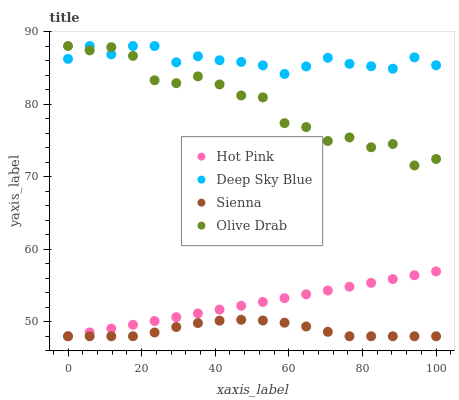Does Sienna have the minimum area under the curve?
Answer yes or no. Yes. Does Deep Sky Blue have the maximum area under the curve?
Answer yes or no. Yes. Does Hot Pink have the minimum area under the curve?
Answer yes or no. No. Does Hot Pink have the maximum area under the curve?
Answer yes or no. No. Is Hot Pink the smoothest?
Answer yes or no. Yes. Is Olive Drab the roughest?
Answer yes or no. Yes. Is Olive Drab the smoothest?
Answer yes or no. No. Is Hot Pink the roughest?
Answer yes or no. No. Does Sienna have the lowest value?
Answer yes or no. Yes. Does Olive Drab have the lowest value?
Answer yes or no. No. Does Deep Sky Blue have the highest value?
Answer yes or no. Yes. Does Hot Pink have the highest value?
Answer yes or no. No. Is Hot Pink less than Deep Sky Blue?
Answer yes or no. Yes. Is Olive Drab greater than Hot Pink?
Answer yes or no. Yes. Does Sienna intersect Hot Pink?
Answer yes or no. Yes. Is Sienna less than Hot Pink?
Answer yes or no. No. Is Sienna greater than Hot Pink?
Answer yes or no. No. Does Hot Pink intersect Deep Sky Blue?
Answer yes or no. No. 